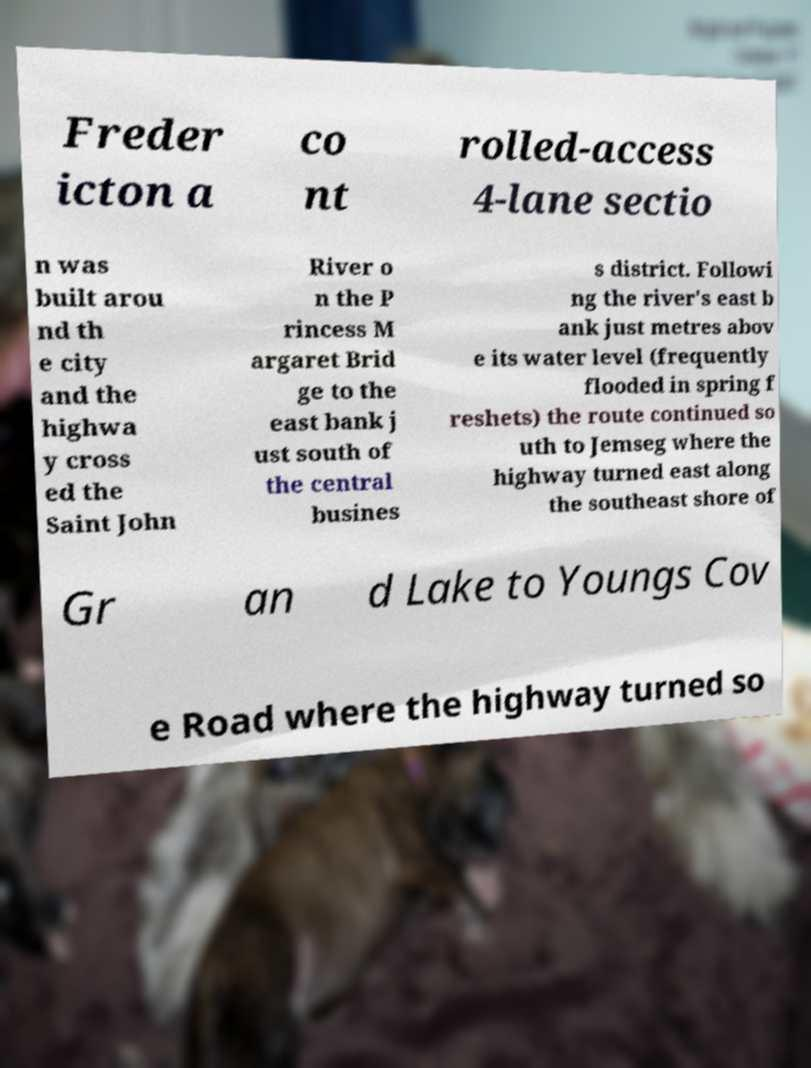Can you accurately transcribe the text from the provided image for me? Freder icton a co nt rolled-access 4-lane sectio n was built arou nd th e city and the highwa y cross ed the Saint John River o n the P rincess M argaret Brid ge to the east bank j ust south of the central busines s district. Followi ng the river's east b ank just metres abov e its water level (frequently flooded in spring f reshets) the route continued so uth to Jemseg where the highway turned east along the southeast shore of Gr an d Lake to Youngs Cov e Road where the highway turned so 